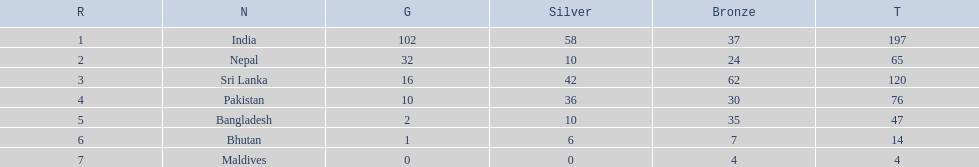How many gold medals were won by the teams? 102, 32, 16, 10, 2, 1, 0. What country won no gold medals? Maldives. 